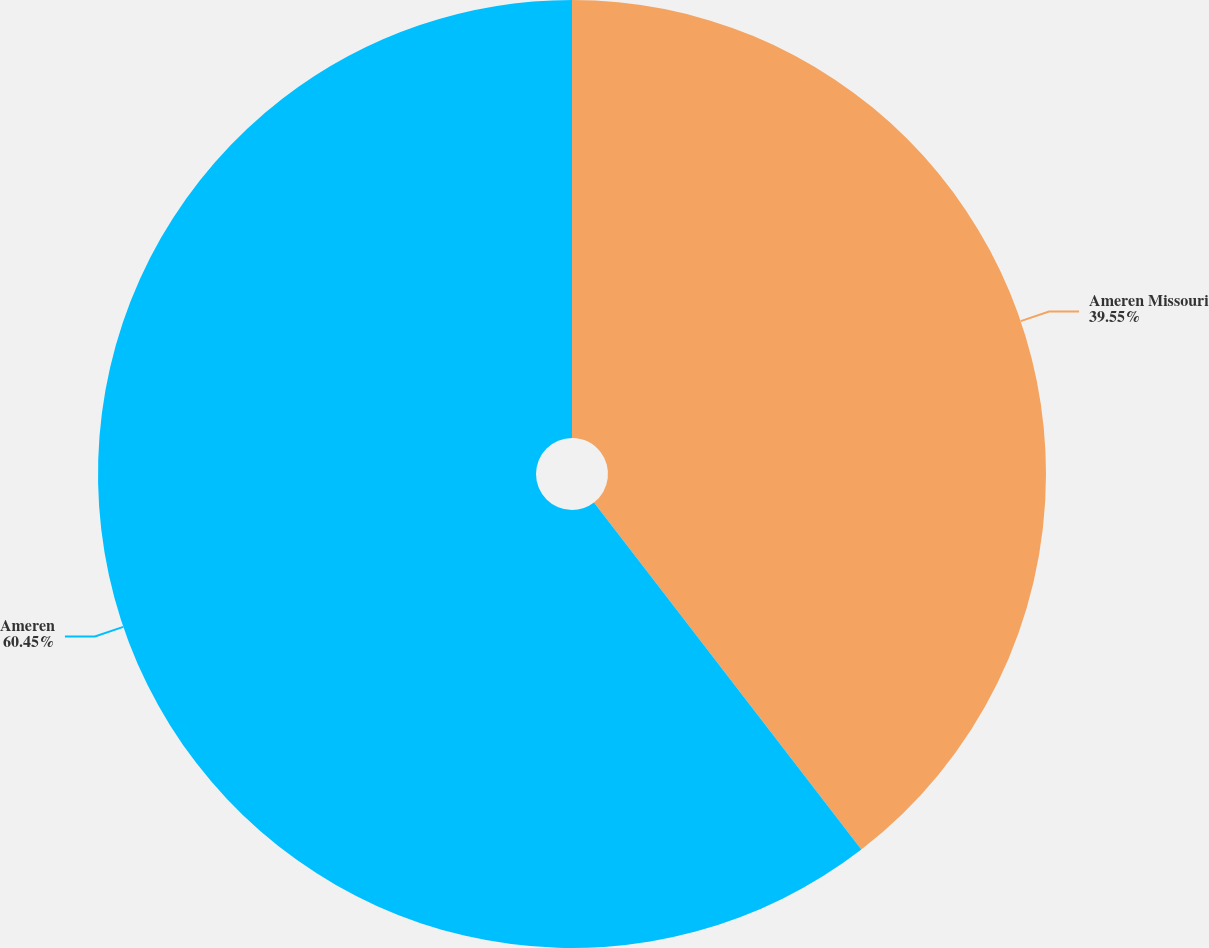Convert chart. <chart><loc_0><loc_0><loc_500><loc_500><pie_chart><fcel>Ameren Missouri<fcel>Ameren<nl><fcel>39.55%<fcel>60.45%<nl></chart> 